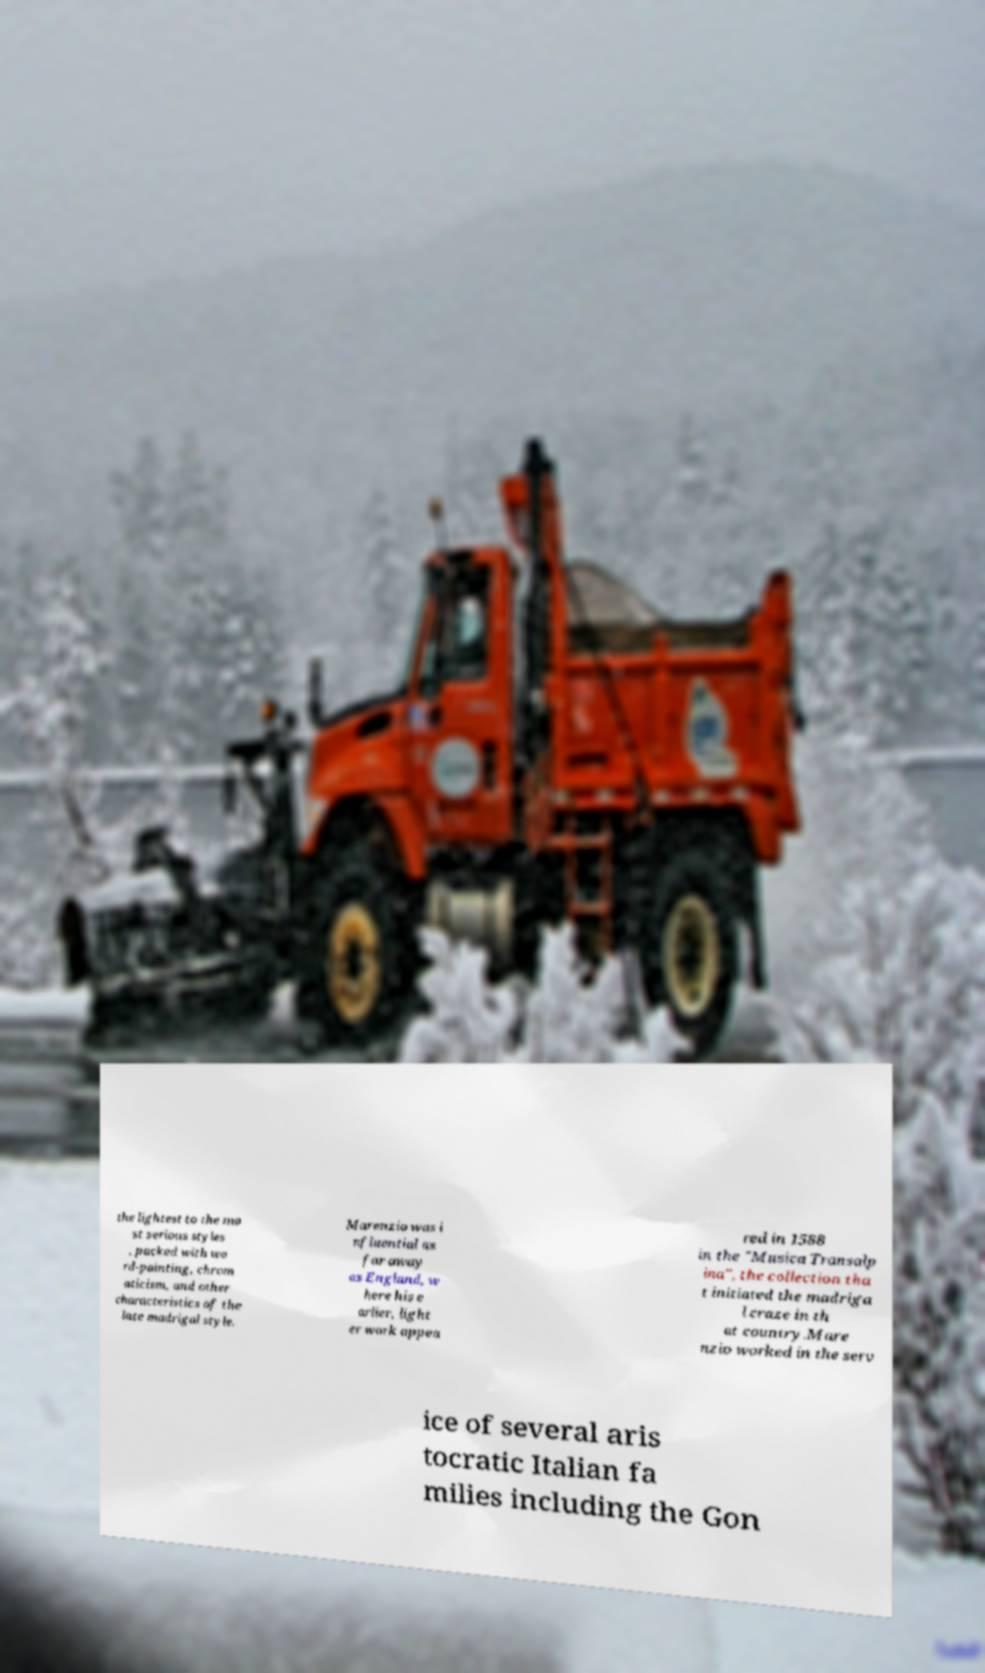Please identify and transcribe the text found in this image. the lightest to the mo st serious styles , packed with wo rd-painting, chrom aticism, and other characteristics of the late madrigal style. Marenzio was i nfluential as far away as England, w here his e arlier, light er work appea red in 1588 in the "Musica Transalp ina", the collection tha t initiated the madriga l craze in th at country.Mare nzio worked in the serv ice of several aris tocratic Italian fa milies including the Gon 